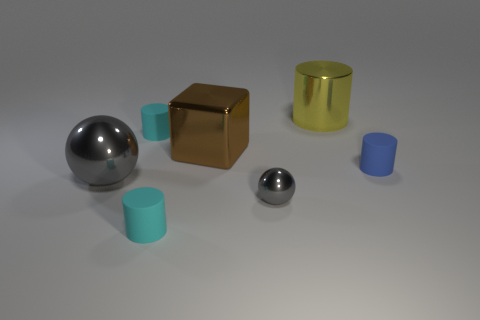Subtract all gray balls. How many cyan cylinders are left? 2 Subtract all blue rubber cylinders. How many cylinders are left? 3 Subtract all blue cylinders. How many cylinders are left? 3 Add 2 large yellow objects. How many objects exist? 9 Subtract all green cylinders. Subtract all brown cubes. How many cylinders are left? 4 Subtract all cylinders. How many objects are left? 3 Add 2 cyan cylinders. How many cyan cylinders are left? 4 Add 5 large metal objects. How many large metal objects exist? 8 Subtract 0 red blocks. How many objects are left? 7 Subtract all small green spheres. Subtract all gray objects. How many objects are left? 5 